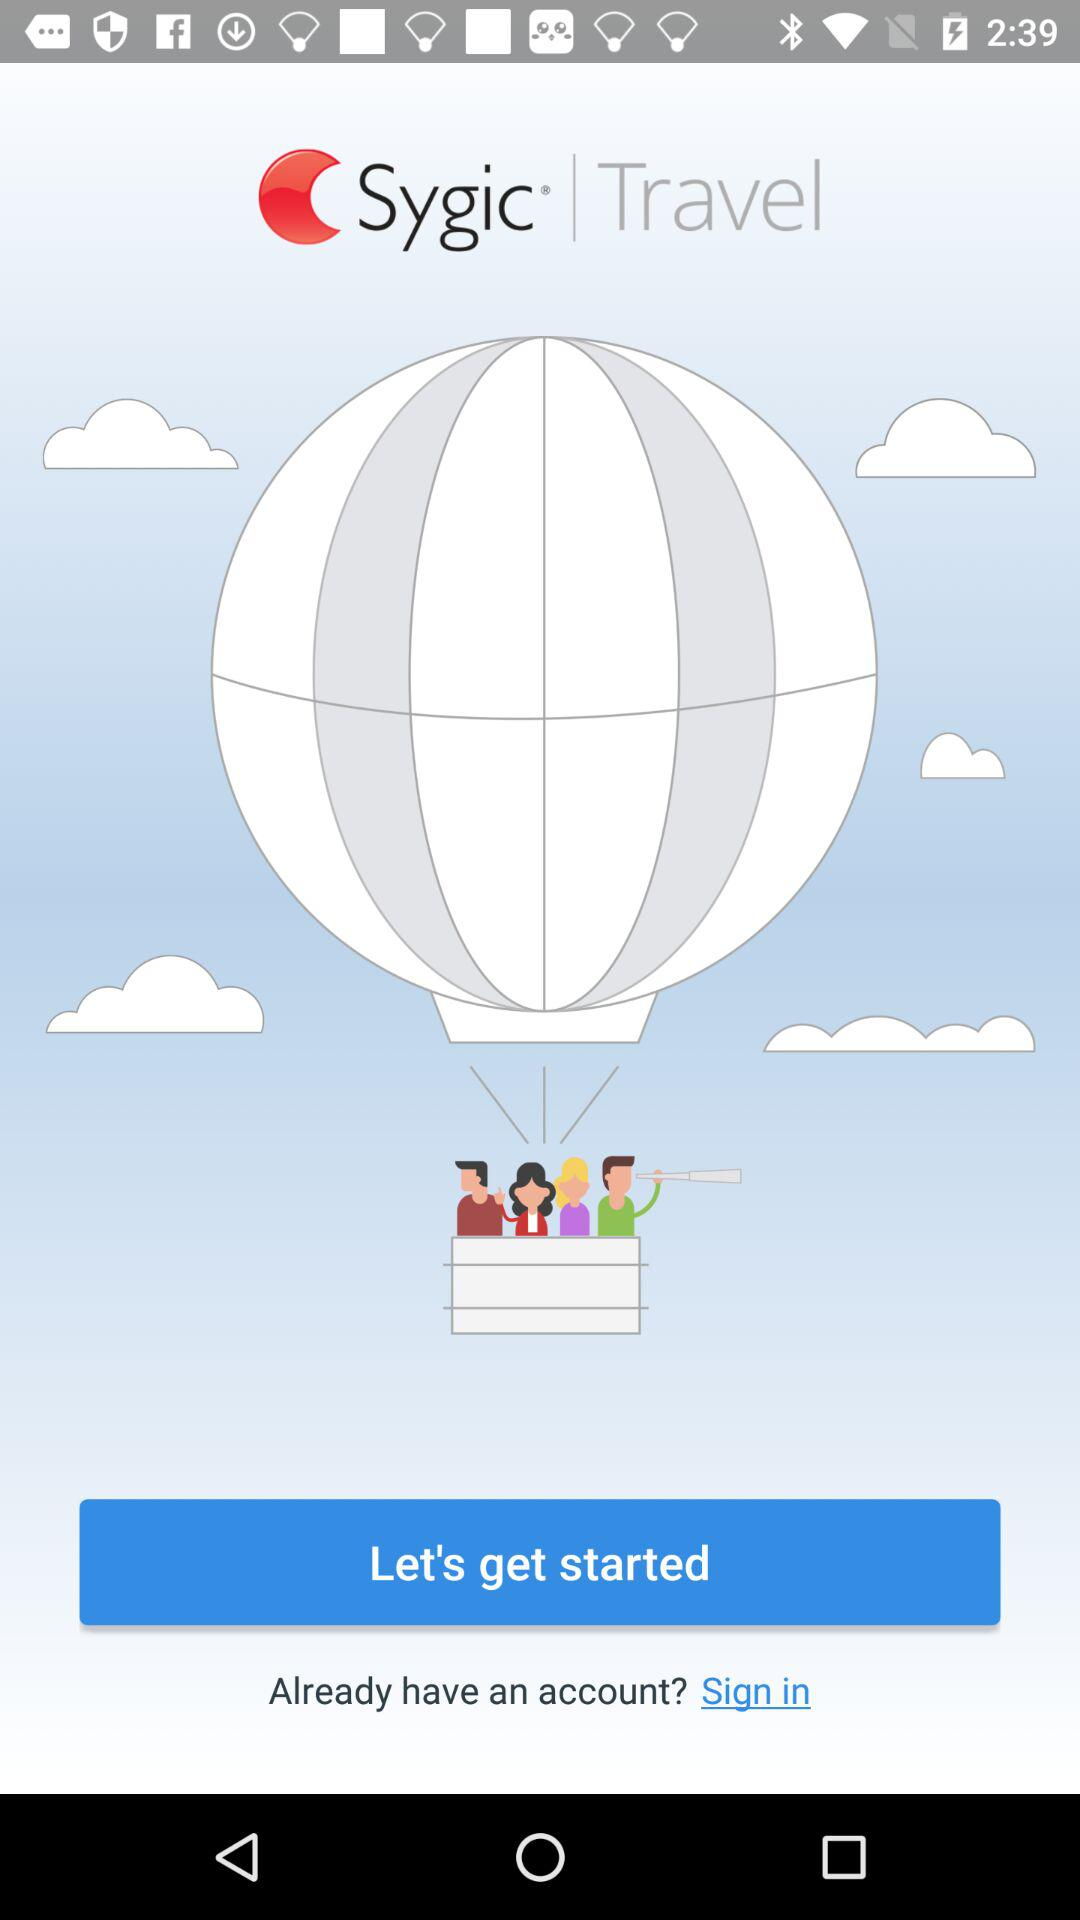What is the company name? The company name is "Sygic". 